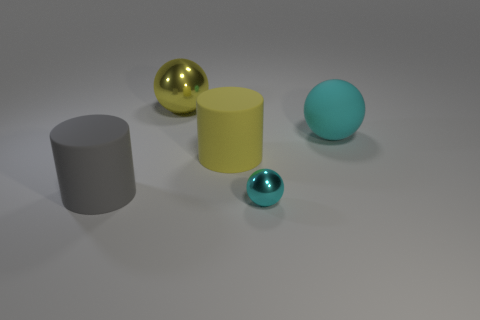What shape is the yellow rubber thing?
Your answer should be compact. Cylinder. Is there a gray cylinder that is behind the metallic ball that is behind the cyan sphere in front of the big matte sphere?
Your answer should be very brief. No. The ball that is behind the large rubber sphere that is right of the cylinder right of the large gray matte thing is what color?
Your answer should be very brief. Yellow. There is a big gray object that is the same shape as the yellow matte thing; what is it made of?
Ensure brevity in your answer.  Rubber. What is the size of the cyan object behind the tiny cyan thing that is to the right of the yellow matte object?
Keep it short and to the point. Large. What material is the big ball right of the yellow rubber cylinder?
Provide a short and direct response. Rubber. There is another ball that is the same material as the yellow ball; what is its size?
Offer a very short reply. Small. What number of tiny cyan metal objects are the same shape as the gray matte thing?
Provide a short and direct response. 0. There is a small shiny object; is it the same shape as the object right of the tiny sphere?
Give a very brief answer. Yes. There is a object that is the same color as the tiny sphere; what shape is it?
Provide a short and direct response. Sphere. 